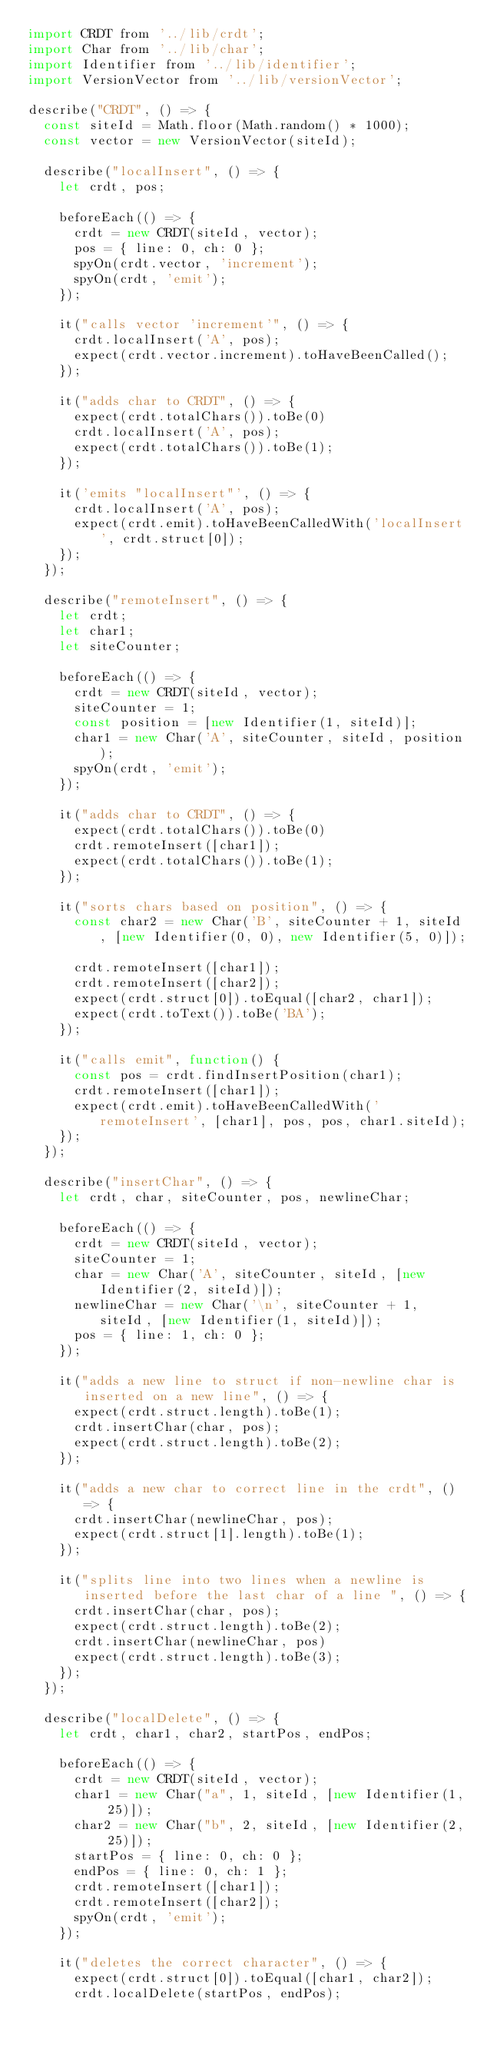<code> <loc_0><loc_0><loc_500><loc_500><_JavaScript_>import CRDT from '../lib/crdt';
import Char from '../lib/char';
import Identifier from '../lib/identifier';
import VersionVector from '../lib/versionVector';

describe("CRDT", () => {
  const siteId = Math.floor(Math.random() * 1000);
  const vector = new VersionVector(siteId);

  describe("localInsert", () => {
    let crdt, pos;

    beforeEach(() => {
      crdt = new CRDT(siteId, vector);
      pos = { line: 0, ch: 0 };
      spyOn(crdt.vector, 'increment');
      spyOn(crdt, 'emit');
    });

    it("calls vector 'increment'", () => {
      crdt.localInsert('A', pos);
      expect(crdt.vector.increment).toHaveBeenCalled();
    });

    it("adds char to CRDT", () => {
      expect(crdt.totalChars()).toBe(0)
      crdt.localInsert('A', pos);
      expect(crdt.totalChars()).toBe(1);
    });

    it('emits "localInsert"', () => {
      crdt.localInsert('A', pos);
      expect(crdt.emit).toHaveBeenCalledWith('localInsert', crdt.struct[0]);
    });
  });

  describe("remoteInsert", () => {
    let crdt;
    let char1;
    let siteCounter;

    beforeEach(() => {
      crdt = new CRDT(siteId, vector);
      siteCounter = 1;
      const position = [new Identifier(1, siteId)];
      char1 = new Char('A', siteCounter, siteId, position);
      spyOn(crdt, 'emit');
    });

    it("adds char to CRDT", () => {
      expect(crdt.totalChars()).toBe(0)
      crdt.remoteInsert([char1]);
      expect(crdt.totalChars()).toBe(1);
    });

    it("sorts chars based on position", () => {
      const char2 = new Char('B', siteCounter + 1, siteId, [new Identifier(0, 0), new Identifier(5, 0)]);

      crdt.remoteInsert([char1]);
      crdt.remoteInsert([char2]);
      expect(crdt.struct[0]).toEqual([char2, char1]);
      expect(crdt.toText()).toBe('BA');
    });

    it("calls emit", function() {
      const pos = crdt.findInsertPosition(char1);
      crdt.remoteInsert([char1]);
      expect(crdt.emit).toHaveBeenCalledWith('remoteInsert', [char1], pos, pos, char1.siteId);
    });
  });

  describe("insertChar", () => {
    let crdt, char, siteCounter, pos, newlineChar;

    beforeEach(() => {
      crdt = new CRDT(siteId, vector);
      siteCounter = 1;
      char = new Char('A', siteCounter, siteId, [new Identifier(2, siteId)]);
      newlineChar = new Char('\n', siteCounter + 1, siteId, [new Identifier(1, siteId)]);
      pos = { line: 1, ch: 0 };
    });

    it("adds a new line to struct if non-newline char is inserted on a new line", () => {
      expect(crdt.struct.length).toBe(1);
      crdt.insertChar(char, pos);
      expect(crdt.struct.length).toBe(2);
    });

    it("adds a new char to correct line in the crdt", () => {
      crdt.insertChar(newlineChar, pos);
      expect(crdt.struct[1].length).toBe(1);
    });

    it("splits line into two lines when a newline is inserted before the last char of a line ", () => {
      crdt.insertChar(char, pos);
      expect(crdt.struct.length).toBe(2);
      crdt.insertChar(newlineChar, pos)
      expect(crdt.struct.length).toBe(3);
    });
  });

  describe("localDelete", () => {
    let crdt, char1, char2, startPos, endPos;

    beforeEach(() => {
      crdt = new CRDT(siteId, vector);
      char1 = new Char("a", 1, siteId, [new Identifier(1, 25)]);
      char2 = new Char("b", 2, siteId, [new Identifier(2, 25)]);
      startPos = { line: 0, ch: 0 };
      endPos = { line: 0, ch: 1 };
      crdt.remoteInsert([char1]);
      crdt.remoteInsert([char2]);
      spyOn(crdt, 'emit');
    });

    it("deletes the correct character", () => {
      expect(crdt.struct[0]).toEqual([char1, char2]);
      crdt.localDelete(startPos, endPos);</code> 